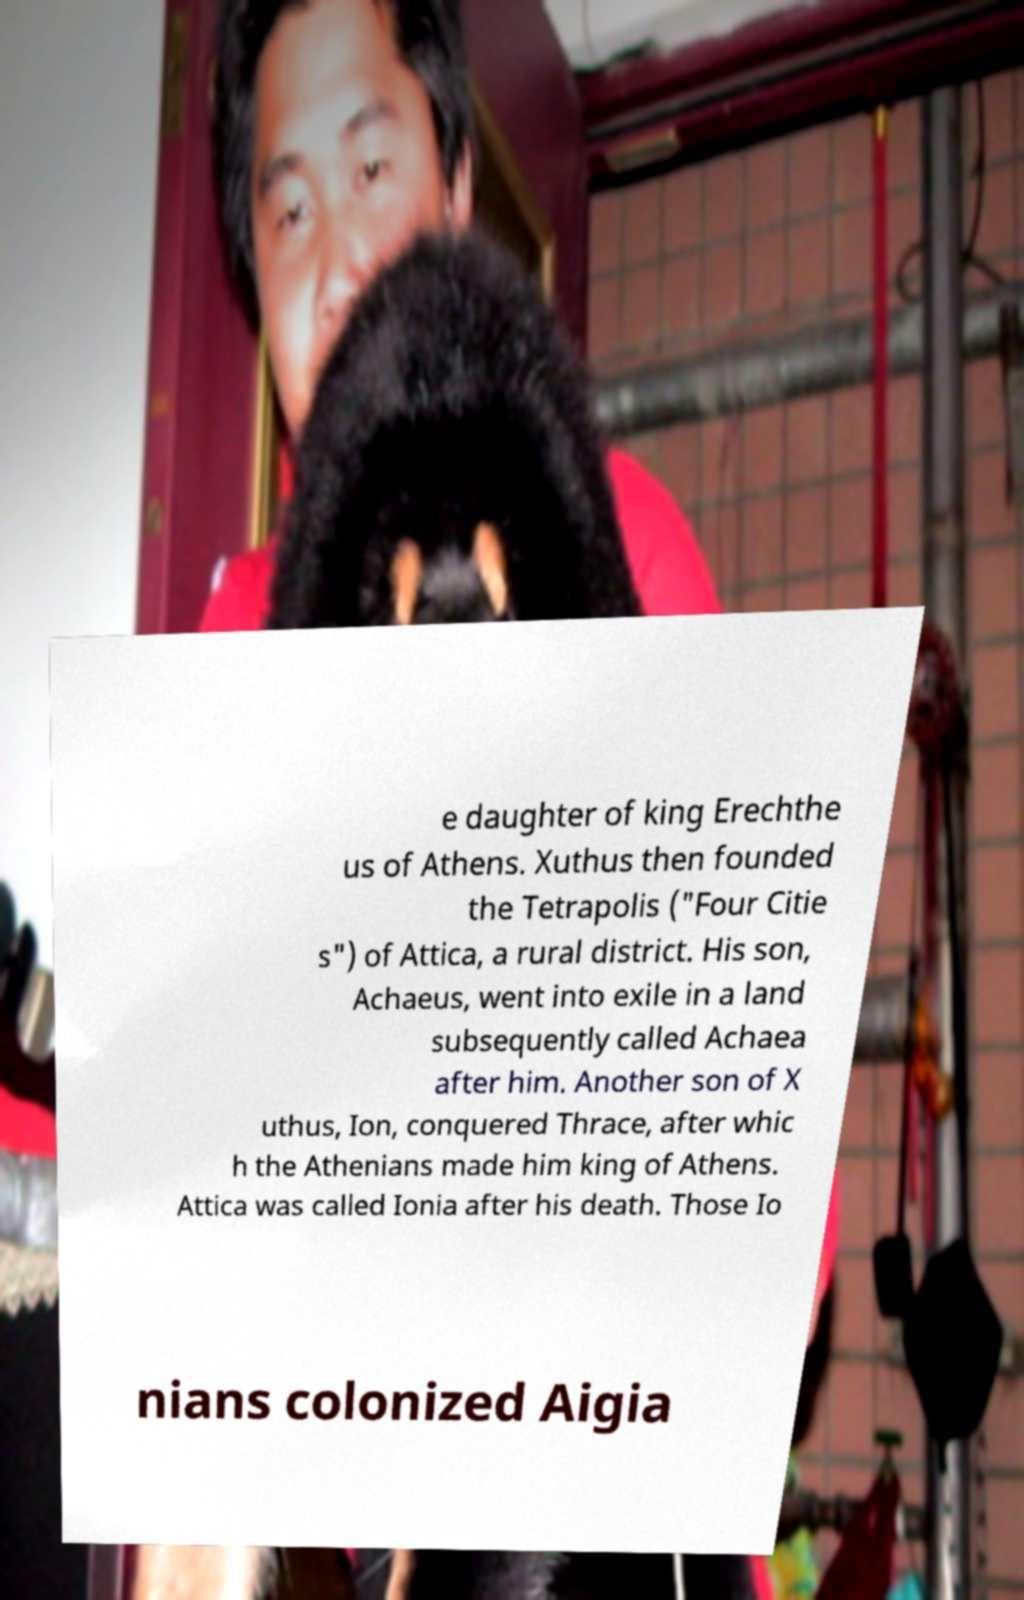Can you read and provide the text displayed in the image?This photo seems to have some interesting text. Can you extract and type it out for me? e daughter of king Erechthe us of Athens. Xuthus then founded the Tetrapolis ("Four Citie s") of Attica, a rural district. His son, Achaeus, went into exile in a land subsequently called Achaea after him. Another son of X uthus, Ion, conquered Thrace, after whic h the Athenians made him king of Athens. Attica was called Ionia after his death. Those Io nians colonized Aigia 